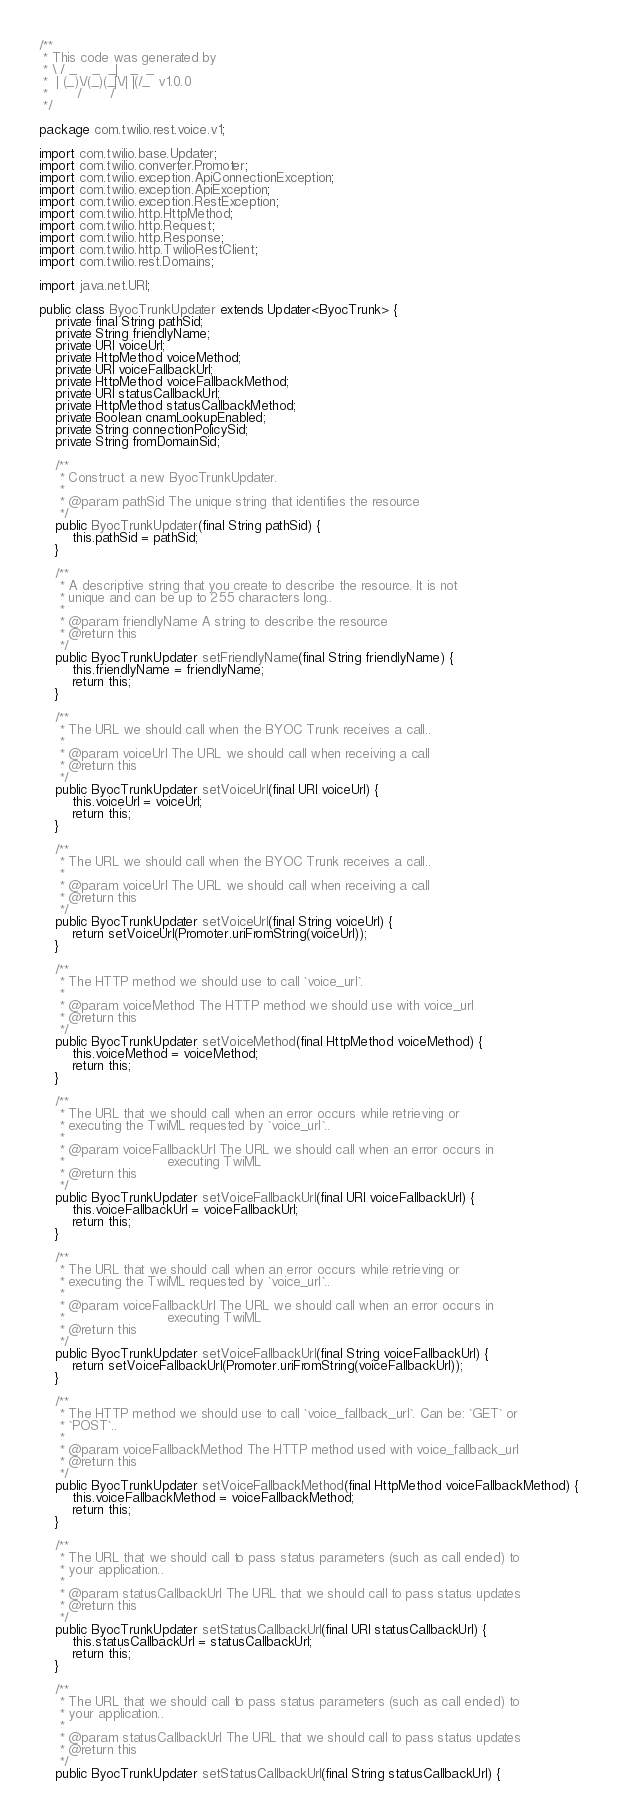Convert code to text. <code><loc_0><loc_0><loc_500><loc_500><_Java_>/**
 * This code was generated by
 * \ / _    _  _|   _  _
 *  | (_)\/(_)(_|\/| |(/_  v1.0.0
 *       /       /
 */

package com.twilio.rest.voice.v1;

import com.twilio.base.Updater;
import com.twilio.converter.Promoter;
import com.twilio.exception.ApiConnectionException;
import com.twilio.exception.ApiException;
import com.twilio.exception.RestException;
import com.twilio.http.HttpMethod;
import com.twilio.http.Request;
import com.twilio.http.Response;
import com.twilio.http.TwilioRestClient;
import com.twilio.rest.Domains;

import java.net.URI;

public class ByocTrunkUpdater extends Updater<ByocTrunk> {
    private final String pathSid;
    private String friendlyName;
    private URI voiceUrl;
    private HttpMethod voiceMethod;
    private URI voiceFallbackUrl;
    private HttpMethod voiceFallbackMethod;
    private URI statusCallbackUrl;
    private HttpMethod statusCallbackMethod;
    private Boolean cnamLookupEnabled;
    private String connectionPolicySid;
    private String fromDomainSid;

    /**
     * Construct a new ByocTrunkUpdater.
     *
     * @param pathSid The unique string that identifies the resource
     */
    public ByocTrunkUpdater(final String pathSid) {
        this.pathSid = pathSid;
    }

    /**
     * A descriptive string that you create to describe the resource. It is not
     * unique and can be up to 255 characters long..
     *
     * @param friendlyName A string to describe the resource
     * @return this
     */
    public ByocTrunkUpdater setFriendlyName(final String friendlyName) {
        this.friendlyName = friendlyName;
        return this;
    }

    /**
     * The URL we should call when the BYOC Trunk receives a call..
     *
     * @param voiceUrl The URL we should call when receiving a call
     * @return this
     */
    public ByocTrunkUpdater setVoiceUrl(final URI voiceUrl) {
        this.voiceUrl = voiceUrl;
        return this;
    }

    /**
     * The URL we should call when the BYOC Trunk receives a call..
     *
     * @param voiceUrl The URL we should call when receiving a call
     * @return this
     */
    public ByocTrunkUpdater setVoiceUrl(final String voiceUrl) {
        return setVoiceUrl(Promoter.uriFromString(voiceUrl));
    }

    /**
     * The HTTP method we should use to call `voice_url`.
     *
     * @param voiceMethod The HTTP method we should use with voice_url
     * @return this
     */
    public ByocTrunkUpdater setVoiceMethod(final HttpMethod voiceMethod) {
        this.voiceMethod = voiceMethod;
        return this;
    }

    /**
     * The URL that we should call when an error occurs while retrieving or
     * executing the TwiML requested by `voice_url`..
     *
     * @param voiceFallbackUrl The URL we should call when an error occurs in
     *                         executing TwiML
     * @return this
     */
    public ByocTrunkUpdater setVoiceFallbackUrl(final URI voiceFallbackUrl) {
        this.voiceFallbackUrl = voiceFallbackUrl;
        return this;
    }

    /**
     * The URL that we should call when an error occurs while retrieving or
     * executing the TwiML requested by `voice_url`..
     *
     * @param voiceFallbackUrl The URL we should call when an error occurs in
     *                         executing TwiML
     * @return this
     */
    public ByocTrunkUpdater setVoiceFallbackUrl(final String voiceFallbackUrl) {
        return setVoiceFallbackUrl(Promoter.uriFromString(voiceFallbackUrl));
    }

    /**
     * The HTTP method we should use to call `voice_fallback_url`. Can be: `GET` or
     * `POST`..
     *
     * @param voiceFallbackMethod The HTTP method used with voice_fallback_url
     * @return this
     */
    public ByocTrunkUpdater setVoiceFallbackMethod(final HttpMethod voiceFallbackMethod) {
        this.voiceFallbackMethod = voiceFallbackMethod;
        return this;
    }

    /**
     * The URL that we should call to pass status parameters (such as call ended) to
     * your application..
     *
     * @param statusCallbackUrl The URL that we should call to pass status updates
     * @return this
     */
    public ByocTrunkUpdater setStatusCallbackUrl(final URI statusCallbackUrl) {
        this.statusCallbackUrl = statusCallbackUrl;
        return this;
    }

    /**
     * The URL that we should call to pass status parameters (such as call ended) to
     * your application..
     *
     * @param statusCallbackUrl The URL that we should call to pass status updates
     * @return this
     */
    public ByocTrunkUpdater setStatusCallbackUrl(final String statusCallbackUrl) {</code> 